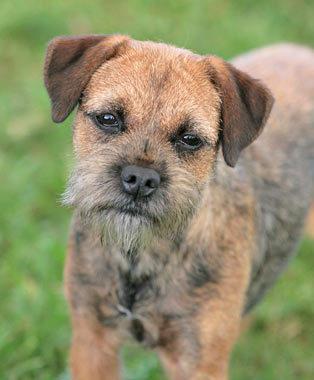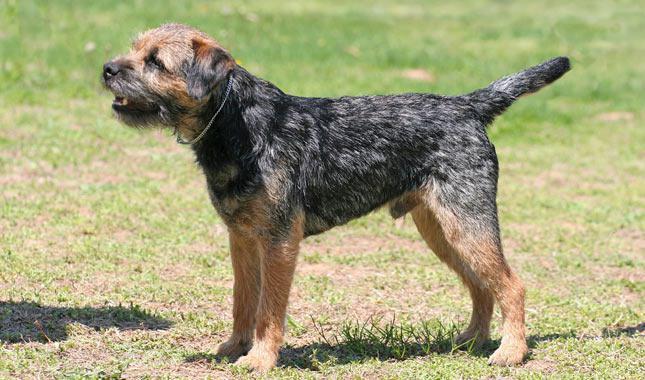The first image is the image on the left, the second image is the image on the right. For the images shown, is this caption "The left image contains a dog facing towards the left." true? Answer yes or no. No. The first image is the image on the left, the second image is the image on the right. Evaluate the accuracy of this statement regarding the images: "A dog stands still in profile facing left with tail extended out.". Is it true? Answer yes or no. Yes. 